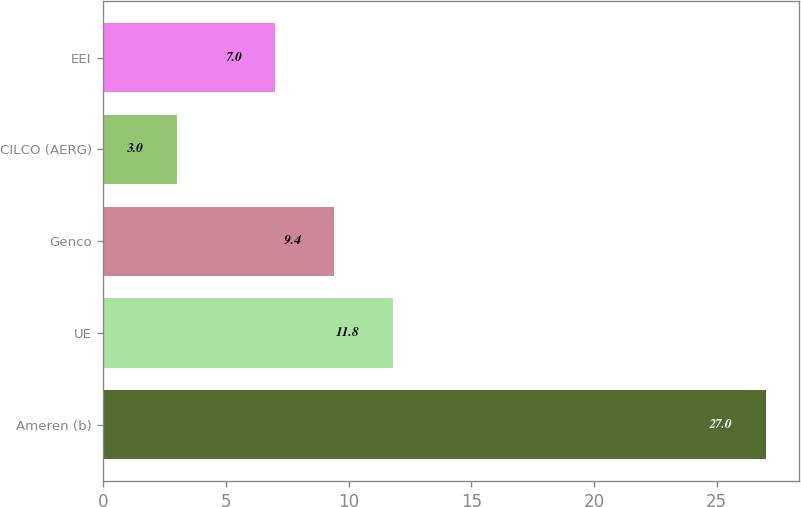Convert chart to OTSL. <chart><loc_0><loc_0><loc_500><loc_500><bar_chart><fcel>Ameren (b)<fcel>UE<fcel>Genco<fcel>CILCO (AERG)<fcel>EEI<nl><fcel>27<fcel>11.8<fcel>9.4<fcel>3<fcel>7<nl></chart> 